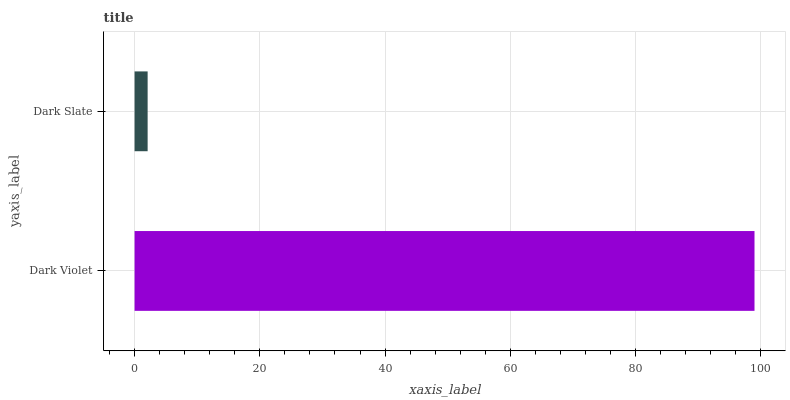Is Dark Slate the minimum?
Answer yes or no. Yes. Is Dark Violet the maximum?
Answer yes or no. Yes. Is Dark Slate the maximum?
Answer yes or no. No. Is Dark Violet greater than Dark Slate?
Answer yes or no. Yes. Is Dark Slate less than Dark Violet?
Answer yes or no. Yes. Is Dark Slate greater than Dark Violet?
Answer yes or no. No. Is Dark Violet less than Dark Slate?
Answer yes or no. No. Is Dark Violet the high median?
Answer yes or no. Yes. Is Dark Slate the low median?
Answer yes or no. Yes. Is Dark Slate the high median?
Answer yes or no. No. Is Dark Violet the low median?
Answer yes or no. No. 